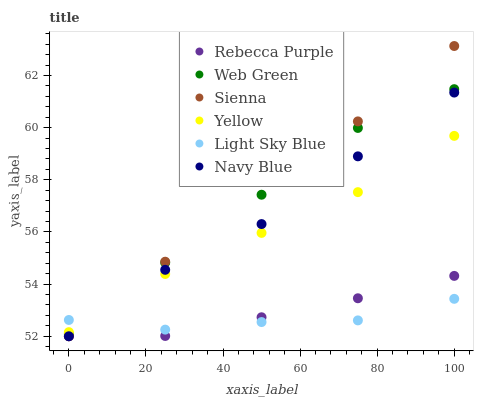Does Light Sky Blue have the minimum area under the curve?
Answer yes or no. Yes. Does Sienna have the maximum area under the curve?
Answer yes or no. Yes. Does Navy Blue have the minimum area under the curve?
Answer yes or no. No. Does Navy Blue have the maximum area under the curve?
Answer yes or no. No. Is Rebecca Purple the smoothest?
Answer yes or no. Yes. Is Sienna the roughest?
Answer yes or no. Yes. Is Navy Blue the smoothest?
Answer yes or no. No. Is Navy Blue the roughest?
Answer yes or no. No. Does Navy Blue have the lowest value?
Answer yes or no. Yes. Does Yellow have the lowest value?
Answer yes or no. No. Does Sienna have the highest value?
Answer yes or no. Yes. Does Navy Blue have the highest value?
Answer yes or no. No. Is Navy Blue less than Web Green?
Answer yes or no. Yes. Is Yellow greater than Rebecca Purple?
Answer yes or no. Yes. Does Light Sky Blue intersect Rebecca Purple?
Answer yes or no. Yes. Is Light Sky Blue less than Rebecca Purple?
Answer yes or no. No. Is Light Sky Blue greater than Rebecca Purple?
Answer yes or no. No. Does Navy Blue intersect Web Green?
Answer yes or no. No. 